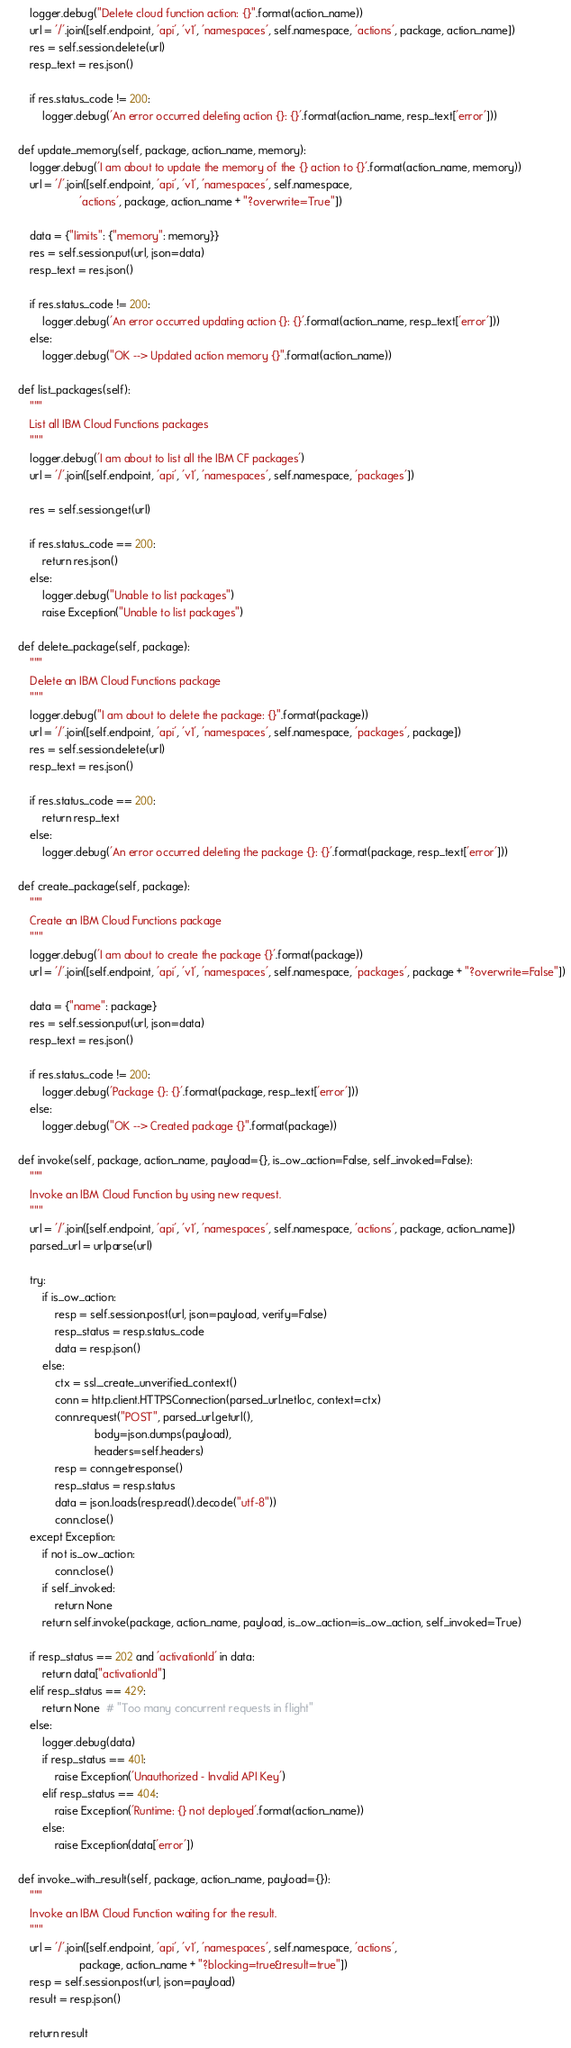Convert code to text. <code><loc_0><loc_0><loc_500><loc_500><_Python_>        logger.debug("Delete cloud function action: {}".format(action_name))
        url = '/'.join([self.endpoint, 'api', 'v1', 'namespaces', self.namespace, 'actions', package, action_name])
        res = self.session.delete(url)
        resp_text = res.json()

        if res.status_code != 200:
            logger.debug('An error occurred deleting action {}: {}'.format(action_name, resp_text['error']))

    def update_memory(self, package, action_name, memory):
        logger.debug('I am about to update the memory of the {} action to {}'.format(action_name, memory))
        url = '/'.join([self.endpoint, 'api', 'v1', 'namespaces', self.namespace,
                        'actions', package, action_name + "?overwrite=True"])

        data = {"limits": {"memory": memory}}
        res = self.session.put(url, json=data)
        resp_text = res.json()

        if res.status_code != 200:
            logger.debug('An error occurred updating action {}: {}'.format(action_name, resp_text['error']))
        else:
            logger.debug("OK --> Updated action memory {}".format(action_name))

    def list_packages(self):
        """
        List all IBM Cloud Functions packages
        """
        logger.debug('I am about to list all the IBM CF packages')
        url = '/'.join([self.endpoint, 'api', 'v1', 'namespaces', self.namespace, 'packages'])

        res = self.session.get(url)

        if res.status_code == 200:
            return res.json()
        else:
            logger.debug("Unable to list packages")
            raise Exception("Unable to list packages")

    def delete_package(self, package):
        """
        Delete an IBM Cloud Functions package
        """
        logger.debug("I am about to delete the package: {}".format(package))
        url = '/'.join([self.endpoint, 'api', 'v1', 'namespaces', self.namespace, 'packages', package])
        res = self.session.delete(url)
        resp_text = res.json()

        if res.status_code == 200:
            return resp_text
        else:
            logger.debug('An error occurred deleting the package {}: {}'.format(package, resp_text['error']))

    def create_package(self, package):
        """
        Create an IBM Cloud Functions package
        """
        logger.debug('I am about to create the package {}'.format(package))
        url = '/'.join([self.endpoint, 'api', 'v1', 'namespaces', self.namespace, 'packages', package + "?overwrite=False"])

        data = {"name": package}
        res = self.session.put(url, json=data)
        resp_text = res.json()

        if res.status_code != 200:
            logger.debug('Package {}: {}'.format(package, resp_text['error']))
        else:
            logger.debug("OK --> Created package {}".format(package))

    def invoke(self, package, action_name, payload={}, is_ow_action=False, self_invoked=False):
        """
        Invoke an IBM Cloud Function by using new request.
        """
        url = '/'.join([self.endpoint, 'api', 'v1', 'namespaces', self.namespace, 'actions', package, action_name])
        parsed_url = urlparse(url)

        try:
            if is_ow_action:
                resp = self.session.post(url, json=payload, verify=False)
                resp_status = resp.status_code
                data = resp.json()
            else:
                ctx = ssl._create_unverified_context()
                conn = http.client.HTTPSConnection(parsed_url.netloc, context=ctx)
                conn.request("POST", parsed_url.geturl(),
                             body=json.dumps(payload),
                             headers=self.headers)
                resp = conn.getresponse()
                resp_status = resp.status
                data = json.loads(resp.read().decode("utf-8"))
                conn.close()
        except Exception:
            if not is_ow_action:
                conn.close()
            if self_invoked:
                return None
            return self.invoke(package, action_name, payload, is_ow_action=is_ow_action, self_invoked=True)

        if resp_status == 202 and 'activationId' in data:
            return data["activationId"]
        elif resp_status == 429:
            return None  # "Too many concurrent requests in flight"
        else:
            logger.debug(data)
            if resp_status == 401:
                raise Exception('Unauthorized - Invalid API Key')
            elif resp_status == 404:
                raise Exception('Runtime: {} not deployed'.format(action_name))
            else:
                raise Exception(data['error'])

    def invoke_with_result(self, package, action_name, payload={}):
        """
        Invoke an IBM Cloud Function waiting for the result.
        """
        url = '/'.join([self.endpoint, 'api', 'v1', 'namespaces', self.namespace, 'actions',
                        package, action_name + "?blocking=true&result=true"])
        resp = self.session.post(url, json=payload)
        result = resp.json()

        return result
</code> 